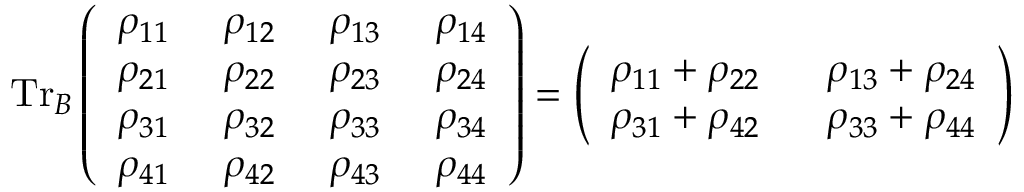<formula> <loc_0><loc_0><loc_500><loc_500>T r _ { B } \left ( \begin{array} { l l l l } { \rho _ { 1 1 } } & { \rho _ { 1 2 } } & { \rho _ { 1 3 } } & { \rho _ { 1 4 } } \\ { \rho _ { 2 1 } } & { \rho _ { 2 2 } } & { \rho _ { 2 3 } } & { \rho _ { 2 4 } } \\ { \rho _ { 3 1 } } & { \rho _ { 3 2 } } & { \rho _ { 3 3 } } & { \rho _ { 3 4 } } \\ { \rho _ { 4 1 } } & { \rho _ { 4 2 } } & { \rho _ { 4 3 } } & { \rho _ { 4 4 } } \end{array} \right ) = \left ( \begin{array} { l l } { \rho _ { 1 1 } + \rho _ { 2 2 } } & { \rho _ { 1 3 } + \rho _ { 2 4 } } \\ { \rho _ { 3 1 } + \rho _ { 4 2 } } & { \rho _ { 3 3 } + \rho _ { 4 4 } } \end{array} \right )</formula> 